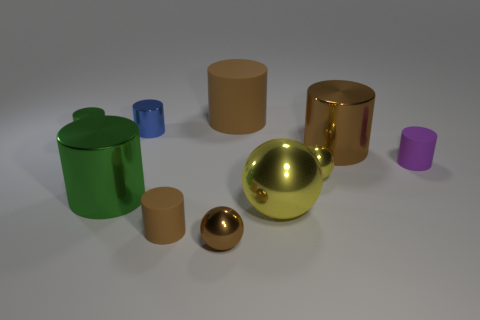Subtract all brown spheres. How many spheres are left? 2 Subtract 3 spheres. How many spheres are left? 0 Subtract all brown cylinders. How many cylinders are left? 4 Subtract all cylinders. How many objects are left? 3 Subtract all brown balls. How many brown cylinders are left? 3 Add 7 purple cylinders. How many purple cylinders are left? 8 Add 7 large gray cylinders. How many large gray cylinders exist? 7 Subtract 0 red balls. How many objects are left? 10 Subtract all brown balls. Subtract all green cubes. How many balls are left? 2 Subtract all tiny cyan metallic cylinders. Subtract all big green shiny things. How many objects are left? 9 